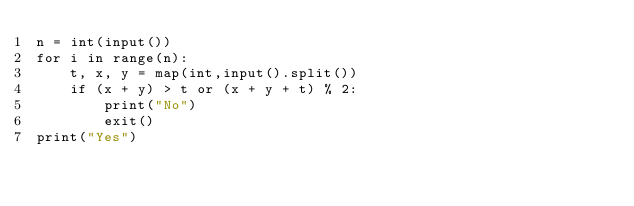Convert code to text. <code><loc_0><loc_0><loc_500><loc_500><_Python_>n = int(input())
for i in range(n):
    t, x, y = map(int,input().split())
    if (x + y) > t or (x + y + t) % 2:
        print("No")
        exit()
print("Yes")</code> 